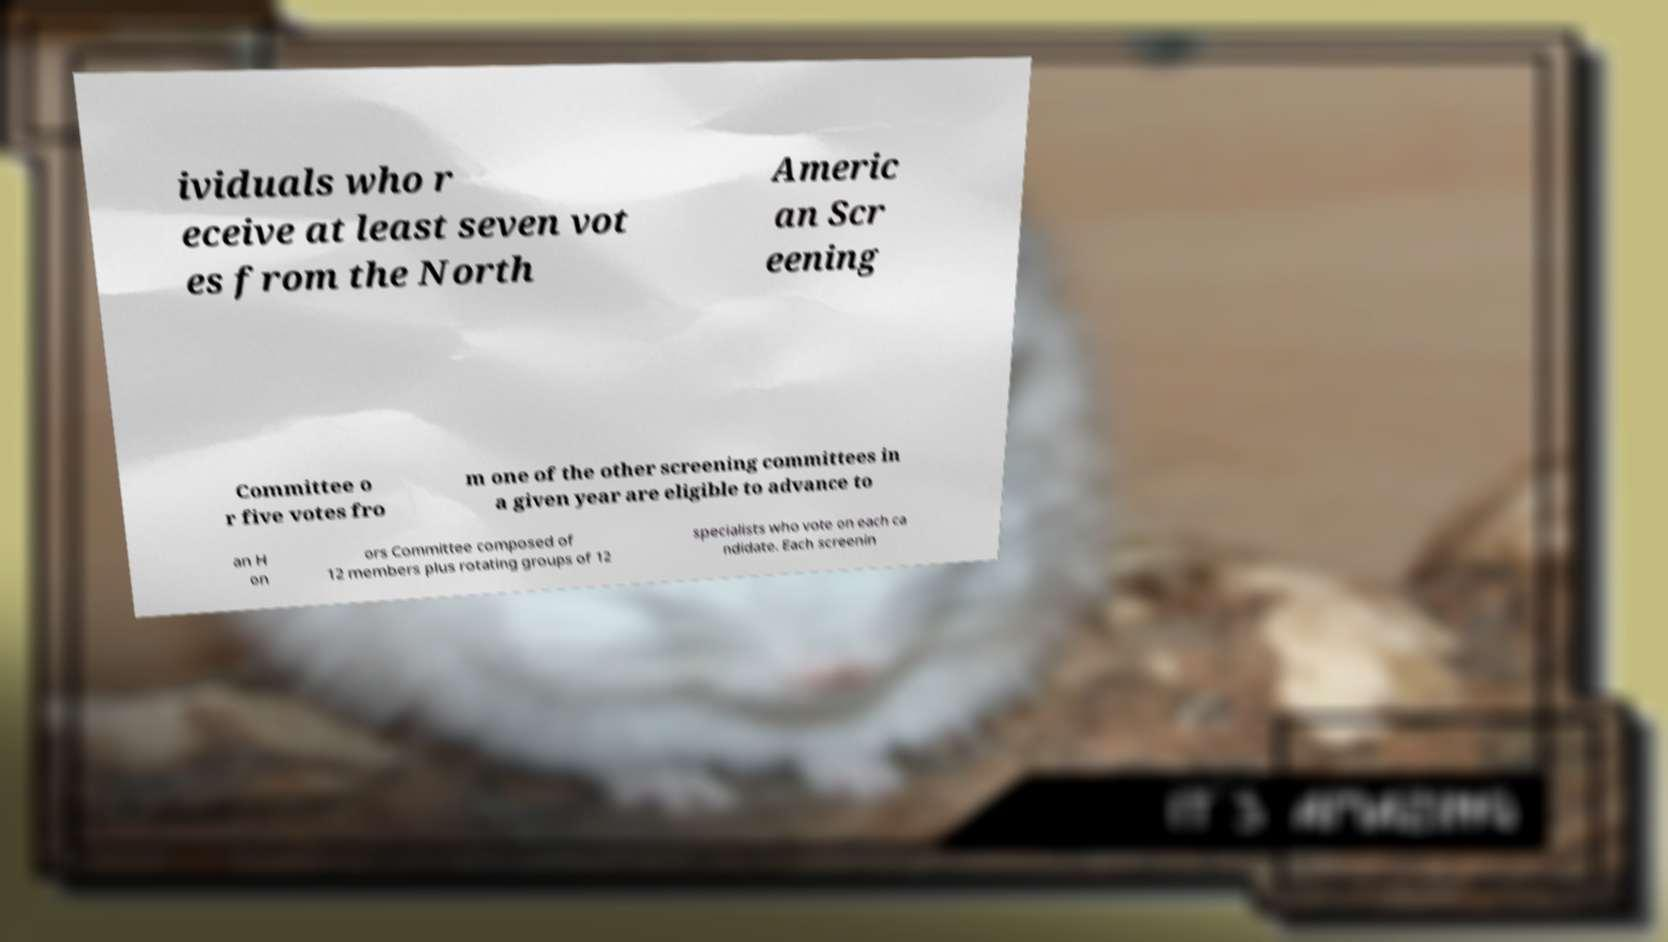For documentation purposes, I need the text within this image transcribed. Could you provide that? ividuals who r eceive at least seven vot es from the North Americ an Scr eening Committee o r five votes fro m one of the other screening committees in a given year are eligible to advance to an H on ors Committee composed of 12 members plus rotating groups of 12 specialists who vote on each ca ndidate. Each screenin 